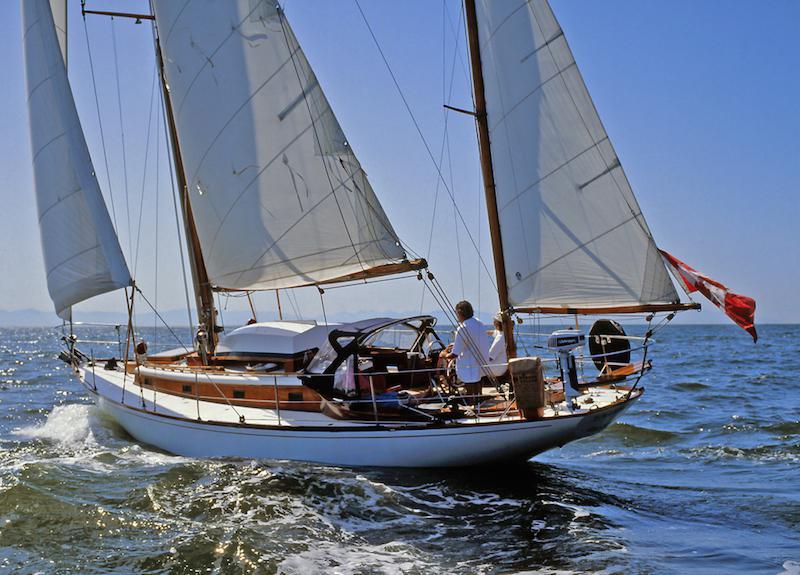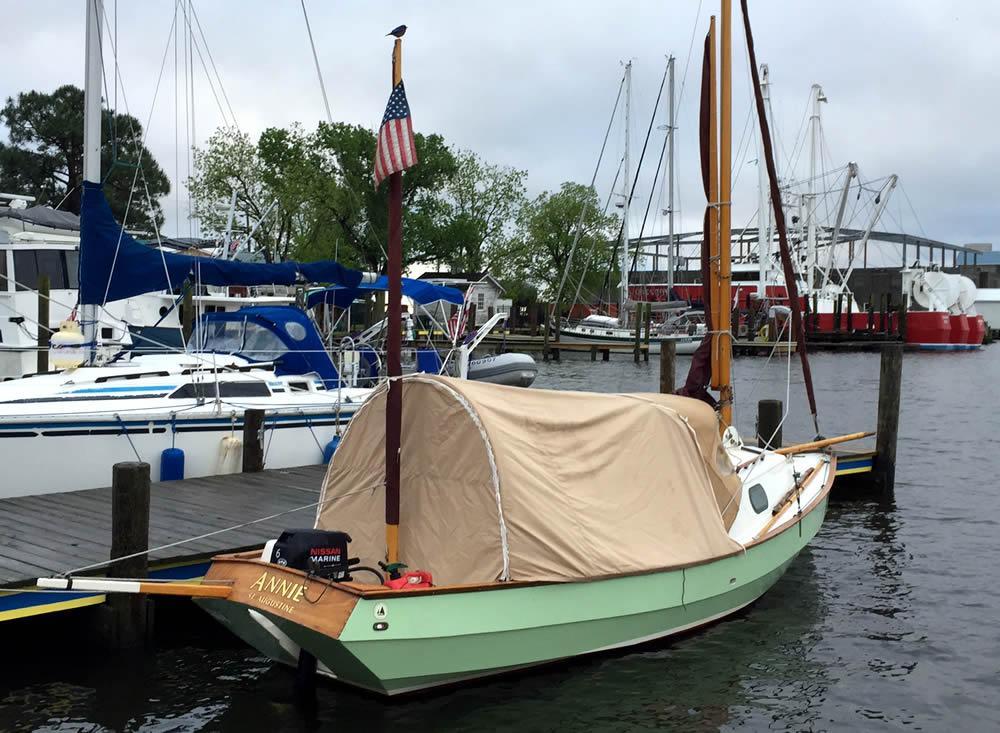The first image is the image on the left, the second image is the image on the right. For the images shown, is this caption "People are in two boats in the water in the image on the left." true? Answer yes or no. No. 